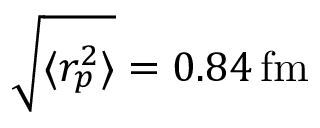Convert formula to latex. <formula><loc_0><loc_0><loc_500><loc_500>\sqrt { \langle r _ { p } ^ { 2 } \rangle } = 0 . 8 4 \, f m</formula> 